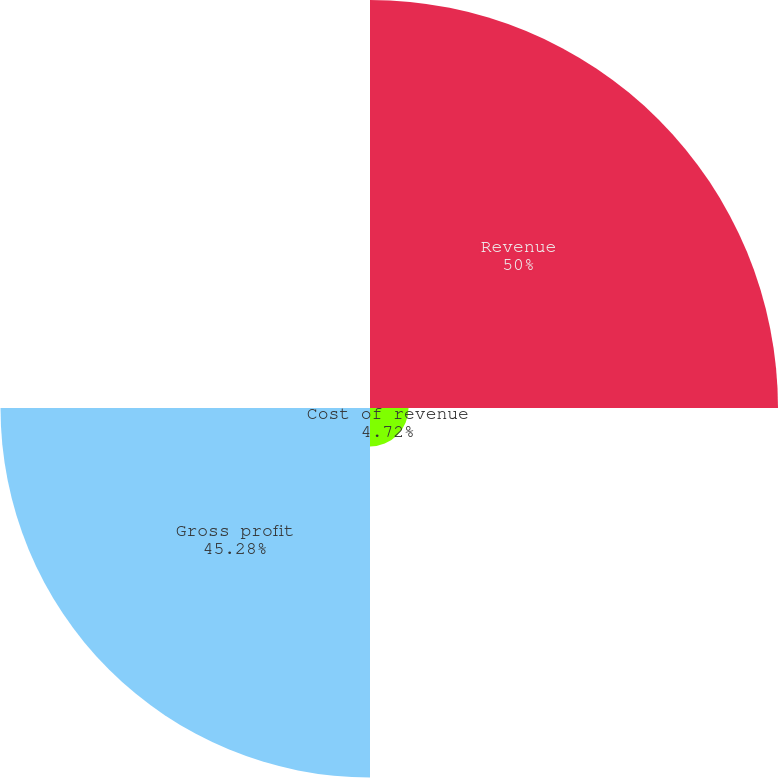Convert chart to OTSL. <chart><loc_0><loc_0><loc_500><loc_500><pie_chart><fcel>Revenue<fcel>Cost of revenue<fcel>Gross profit<fcel>Gross profit as a percentage<nl><fcel>50.0%<fcel>4.72%<fcel>45.28%<fcel>0.0%<nl></chart> 